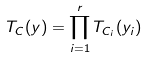Convert formula to latex. <formula><loc_0><loc_0><loc_500><loc_500>T _ { C } ( y ) = \prod _ { i = 1 } ^ { r } T _ { C _ { i } } ( y _ { i } )</formula> 